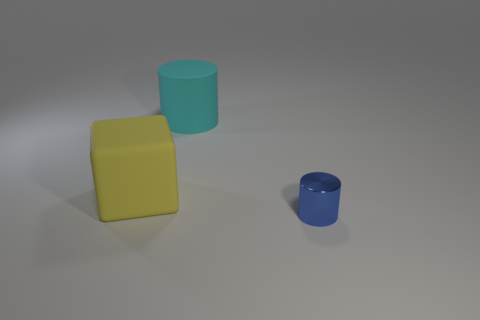Is there any other thing that is the same material as the blue object?
Offer a very short reply. No. Are there any other things that have the same shape as the yellow rubber object?
Give a very brief answer. No. There is another thing that is the same shape as the tiny blue thing; what is its color?
Offer a terse response. Cyan. What shape is the rubber thing right of the matte block?
Provide a short and direct response. Cylinder. There is a yellow object; are there any big cyan rubber cylinders on the right side of it?
Keep it short and to the point. Yes. Are there any other things that have the same size as the yellow matte block?
Ensure brevity in your answer.  Yes. What color is the big cylinder that is made of the same material as the yellow block?
Your response must be concise. Cyan. What number of spheres are metal things or tiny cyan shiny things?
Your answer should be compact. 0. Are there an equal number of shiny objects that are in front of the metal object and large matte objects?
Your response must be concise. No. There is a thing in front of the big rubber object that is in front of the cylinder behind the yellow matte block; what is its material?
Give a very brief answer. Metal. 